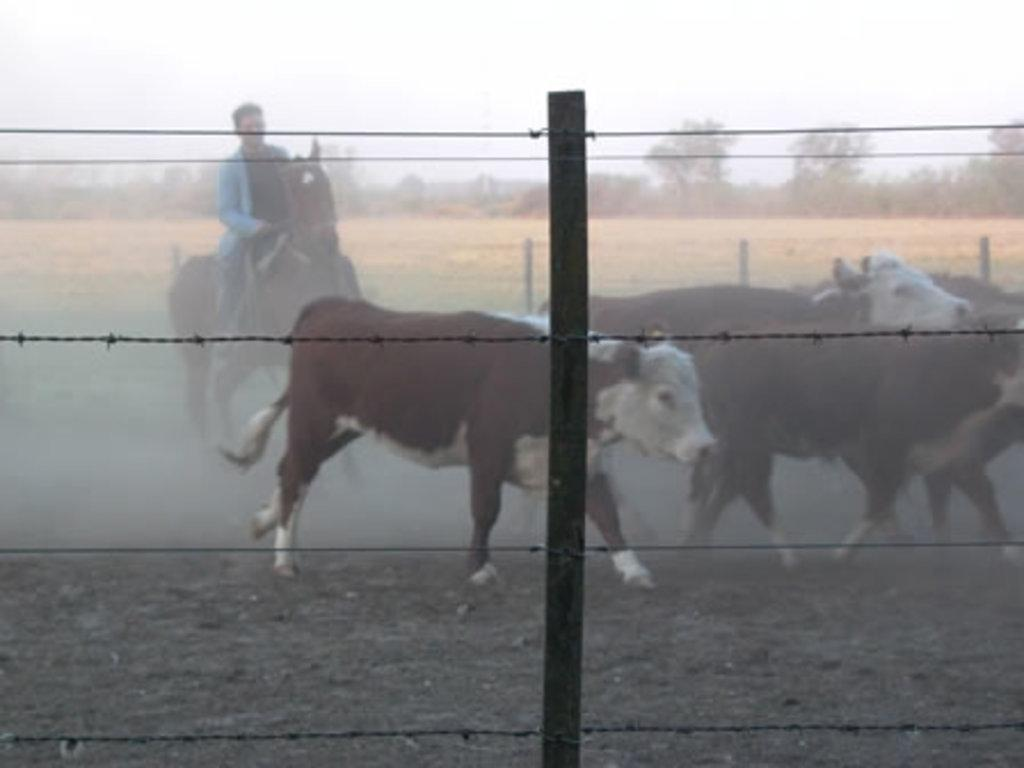What is the main subject of the image? There is a person riding a horse in the image. What else can be seen in the image besides the person on the horse? There are cattle running on the right side of the image. What type of vegetation is visible in the background of the image? There are trees in the background of the image. What is the condition of the sky in the image? The sky is clear in the image. Where is the queen standing in the image? There is no queen present in the image; it features a person riding a horse and cattle running. What type of servant is attending to the person on the horse in the image? There is no servant present in the image; the person riding the horse appears to be alone. 